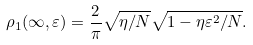Convert formula to latex. <formula><loc_0><loc_0><loc_500><loc_500>\rho _ { 1 } ( \infty , \varepsilon ) = \frac { 2 } { \pi } \sqrt { \eta / N } \sqrt { 1 - \eta \varepsilon ^ { 2 } / N } .</formula> 